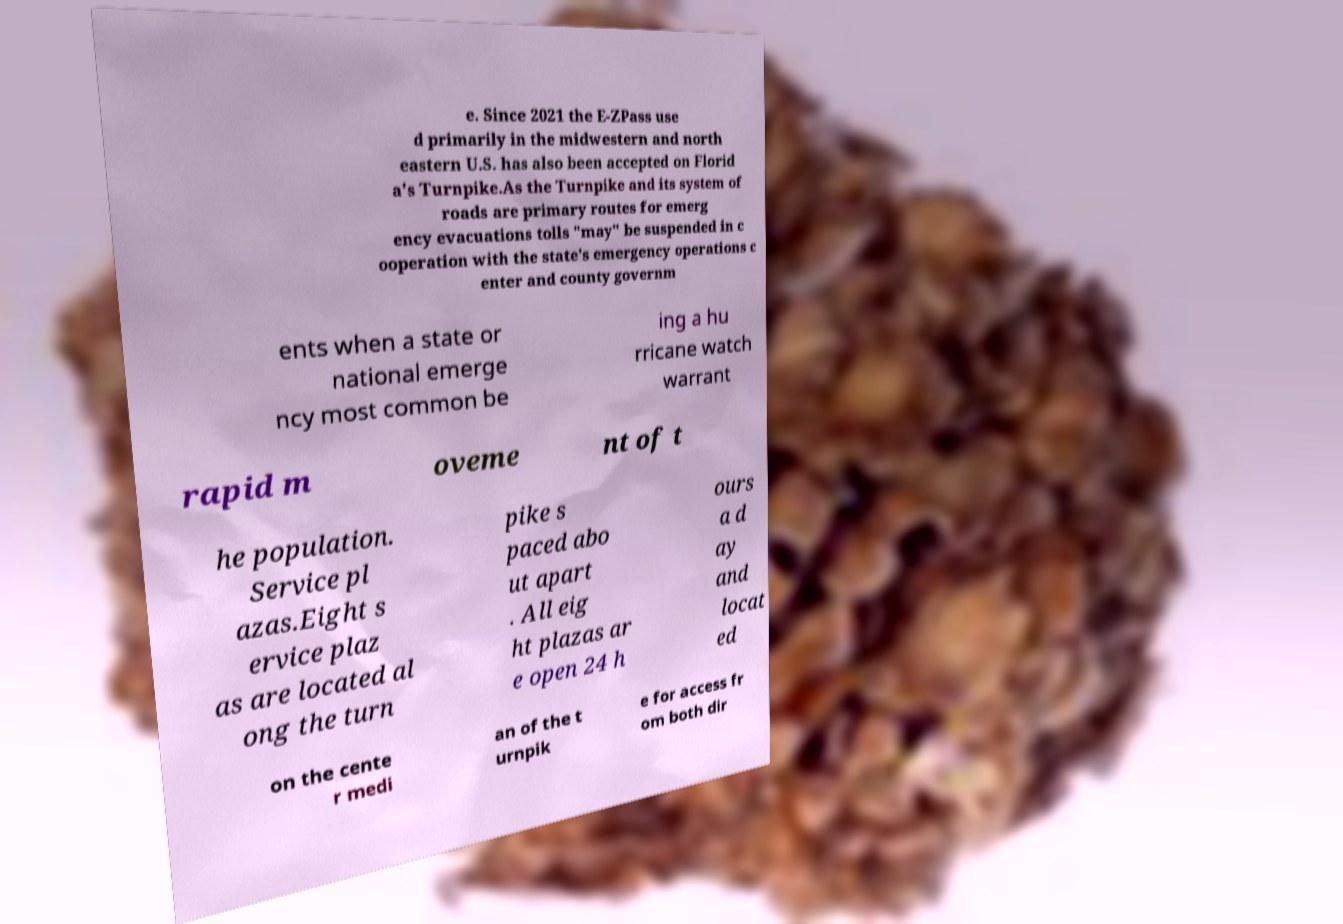Could you assist in decoding the text presented in this image and type it out clearly? e. Since 2021 the E-ZPass use d primarily in the midwestern and north eastern U.S. has also been accepted on Florid a's Turnpike.As the Turnpike and its system of roads are primary routes for emerg ency evacuations tolls "may" be suspended in c ooperation with the state's emergency operations c enter and county governm ents when a state or national emerge ncy most common be ing a hu rricane watch warrant rapid m oveme nt of t he population. Service pl azas.Eight s ervice plaz as are located al ong the turn pike s paced abo ut apart . All eig ht plazas ar e open 24 h ours a d ay and locat ed on the cente r medi an of the t urnpik e for access fr om both dir 